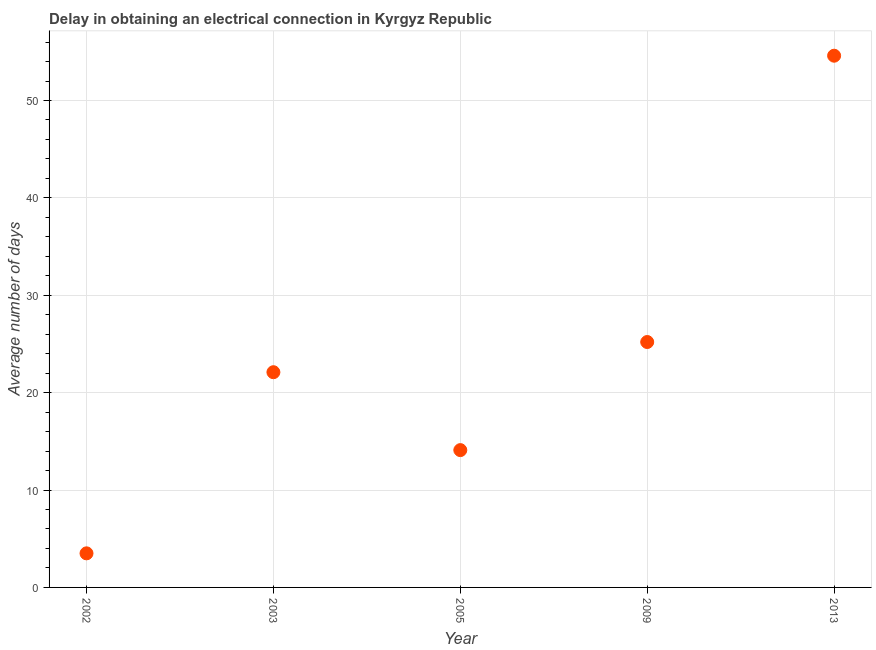What is the dalay in electrical connection in 2003?
Offer a very short reply. 22.1. Across all years, what is the maximum dalay in electrical connection?
Offer a very short reply. 54.6. In which year was the dalay in electrical connection maximum?
Offer a terse response. 2013. What is the sum of the dalay in electrical connection?
Provide a succinct answer. 119.5. What is the difference between the dalay in electrical connection in 2005 and 2013?
Your answer should be compact. -40.5. What is the average dalay in electrical connection per year?
Your response must be concise. 23.9. What is the median dalay in electrical connection?
Your answer should be very brief. 22.1. What is the ratio of the dalay in electrical connection in 2003 to that in 2013?
Your answer should be compact. 0.4. Is the dalay in electrical connection in 2003 less than that in 2005?
Provide a short and direct response. No. What is the difference between the highest and the second highest dalay in electrical connection?
Give a very brief answer. 29.4. Is the sum of the dalay in electrical connection in 2009 and 2013 greater than the maximum dalay in electrical connection across all years?
Ensure brevity in your answer.  Yes. What is the difference between the highest and the lowest dalay in electrical connection?
Offer a very short reply. 51.1. In how many years, is the dalay in electrical connection greater than the average dalay in electrical connection taken over all years?
Ensure brevity in your answer.  2. Does the dalay in electrical connection monotonically increase over the years?
Your answer should be compact. No. Does the graph contain grids?
Your answer should be compact. Yes. What is the title of the graph?
Your answer should be very brief. Delay in obtaining an electrical connection in Kyrgyz Republic. What is the label or title of the X-axis?
Make the answer very short. Year. What is the label or title of the Y-axis?
Give a very brief answer. Average number of days. What is the Average number of days in 2002?
Your response must be concise. 3.5. What is the Average number of days in 2003?
Keep it short and to the point. 22.1. What is the Average number of days in 2005?
Provide a succinct answer. 14.1. What is the Average number of days in 2009?
Your answer should be compact. 25.2. What is the Average number of days in 2013?
Your answer should be very brief. 54.6. What is the difference between the Average number of days in 2002 and 2003?
Your answer should be compact. -18.6. What is the difference between the Average number of days in 2002 and 2009?
Ensure brevity in your answer.  -21.7. What is the difference between the Average number of days in 2002 and 2013?
Give a very brief answer. -51.1. What is the difference between the Average number of days in 2003 and 2013?
Your answer should be very brief. -32.5. What is the difference between the Average number of days in 2005 and 2009?
Your answer should be very brief. -11.1. What is the difference between the Average number of days in 2005 and 2013?
Your response must be concise. -40.5. What is the difference between the Average number of days in 2009 and 2013?
Provide a succinct answer. -29.4. What is the ratio of the Average number of days in 2002 to that in 2003?
Provide a succinct answer. 0.16. What is the ratio of the Average number of days in 2002 to that in 2005?
Your answer should be very brief. 0.25. What is the ratio of the Average number of days in 2002 to that in 2009?
Offer a very short reply. 0.14. What is the ratio of the Average number of days in 2002 to that in 2013?
Offer a very short reply. 0.06. What is the ratio of the Average number of days in 2003 to that in 2005?
Provide a short and direct response. 1.57. What is the ratio of the Average number of days in 2003 to that in 2009?
Offer a very short reply. 0.88. What is the ratio of the Average number of days in 2003 to that in 2013?
Give a very brief answer. 0.41. What is the ratio of the Average number of days in 2005 to that in 2009?
Offer a terse response. 0.56. What is the ratio of the Average number of days in 2005 to that in 2013?
Your answer should be compact. 0.26. What is the ratio of the Average number of days in 2009 to that in 2013?
Give a very brief answer. 0.46. 